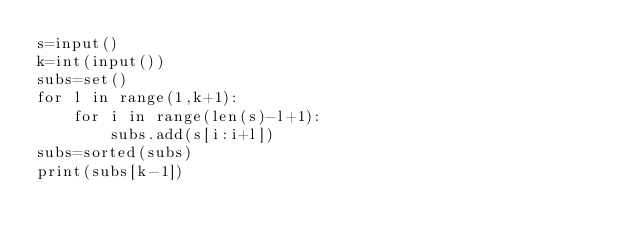<code> <loc_0><loc_0><loc_500><loc_500><_Python_>s=input()
k=int(input())
subs=set()
for l in range(1,k+1):
    for i in range(len(s)-l+1):
        subs.add(s[i:i+l])
subs=sorted(subs)
print(subs[k-1])
</code> 